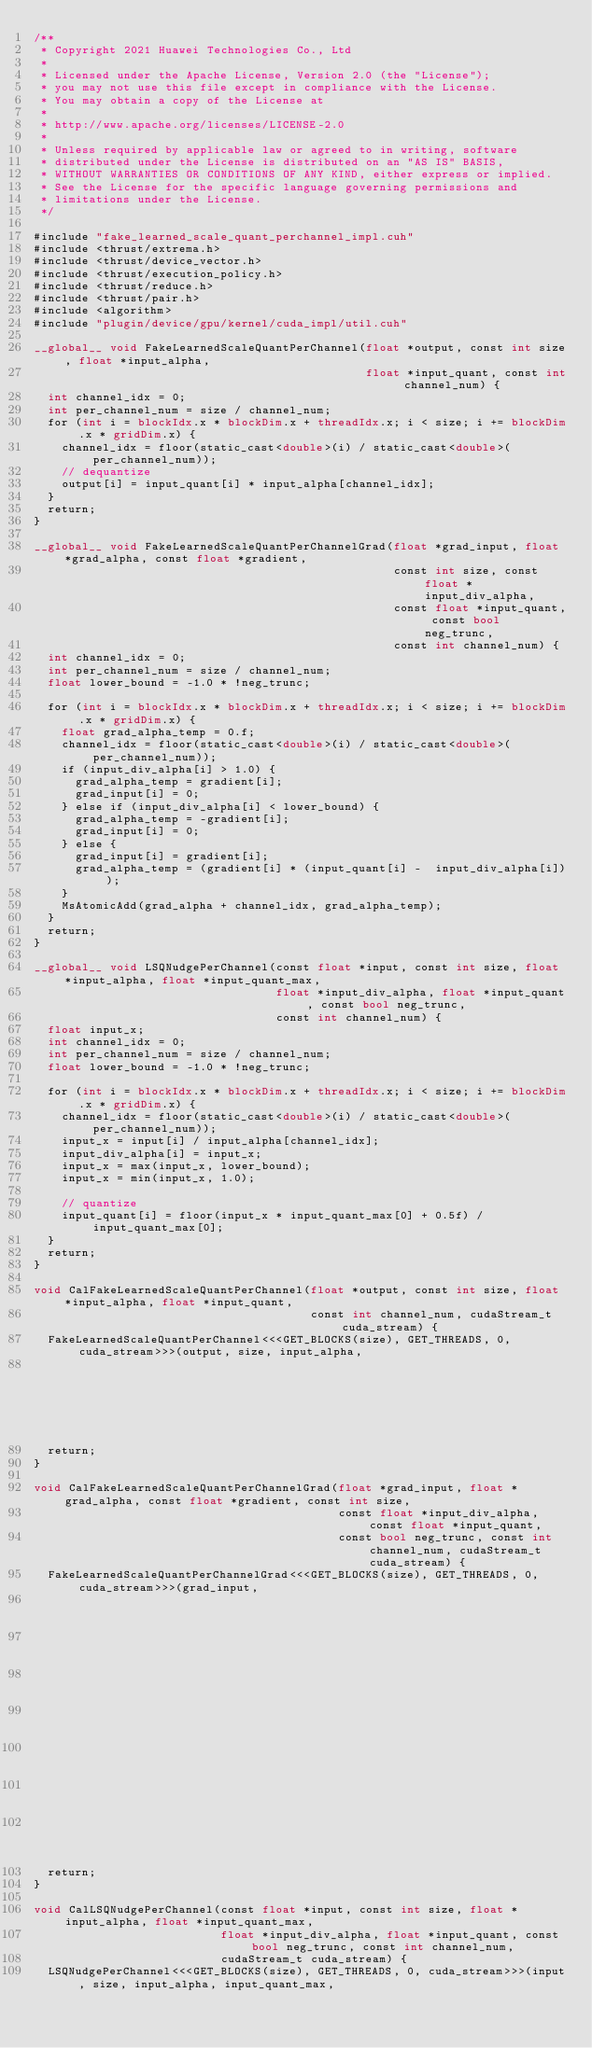<code> <loc_0><loc_0><loc_500><loc_500><_Cuda_>/**
 * Copyright 2021 Huawei Technologies Co., Ltd
 *
 * Licensed under the Apache License, Version 2.0 (the "License");
 * you may not use this file except in compliance with the License.
 * You may obtain a copy of the License at
 *
 * http://www.apache.org/licenses/LICENSE-2.0
 *
 * Unless required by applicable law or agreed to in writing, software
 * distributed under the License is distributed on an "AS IS" BASIS,
 * WITHOUT WARRANTIES OR CONDITIONS OF ANY KIND, either express or implied.
 * See the License for the specific language governing permissions and
 * limitations under the License.
 */

#include "fake_learned_scale_quant_perchannel_impl.cuh"
#include <thrust/extrema.h>
#include <thrust/device_vector.h>
#include <thrust/execution_policy.h>
#include <thrust/reduce.h>
#include <thrust/pair.h>
#include <algorithm>
#include "plugin/device/gpu/kernel/cuda_impl/util.cuh"

__global__ void FakeLearnedScaleQuantPerChannel(float *output, const int size, float *input_alpha,
                                                float *input_quant, const int channel_num) {
  int channel_idx = 0;
  int per_channel_num = size / channel_num;
  for (int i = blockIdx.x * blockDim.x + threadIdx.x; i < size; i += blockDim.x * gridDim.x) {
    channel_idx = floor(static_cast<double>(i) / static_cast<double>(per_channel_num));
    // dequantize
    output[i] = input_quant[i] * input_alpha[channel_idx];
  }
  return;
}

__global__ void FakeLearnedScaleQuantPerChannelGrad(float *grad_input, float *grad_alpha, const float *gradient,
                                                    const int size, const float *input_div_alpha,
                                                    const float *input_quant, const bool neg_trunc,
                                                    const int channel_num) {
  int channel_idx = 0;
  int per_channel_num = size / channel_num;
  float lower_bound = -1.0 * !neg_trunc;

  for (int i = blockIdx.x * blockDim.x + threadIdx.x; i < size; i += blockDim.x * gridDim.x) {
    float grad_alpha_temp = 0.f;
    channel_idx = floor(static_cast<double>(i) / static_cast<double>(per_channel_num));
    if (input_div_alpha[i] > 1.0) {
      grad_alpha_temp = gradient[i];
      grad_input[i] = 0;
    } else if (input_div_alpha[i] < lower_bound) {
      grad_alpha_temp = -gradient[i];
      grad_input[i] = 0;
    } else {
      grad_input[i] = gradient[i];
      grad_alpha_temp = (gradient[i] * (input_quant[i] -  input_div_alpha[i]));
    }
    MsAtomicAdd(grad_alpha + channel_idx, grad_alpha_temp);
  }
  return;
}

__global__ void LSQNudgePerChannel(const float *input, const int size, float *input_alpha, float *input_quant_max,
                                   float *input_div_alpha, float *input_quant, const bool neg_trunc,
                                   const int channel_num) {
  float input_x;
  int channel_idx = 0;
  int per_channel_num = size / channel_num;
  float lower_bound = -1.0 * !neg_trunc;

  for (int i = blockIdx.x * blockDim.x + threadIdx.x; i < size; i += blockDim.x * gridDim.x) {
    channel_idx = floor(static_cast<double>(i) / static_cast<double>(per_channel_num));
    input_x = input[i] / input_alpha[channel_idx];
    input_div_alpha[i] = input_x;
    input_x = max(input_x, lower_bound);
    input_x = min(input_x, 1.0);

    // quantize
    input_quant[i] = floor(input_x * input_quant_max[0] + 0.5f) / input_quant_max[0];
  }
  return;
}

void CalFakeLearnedScaleQuantPerChannel(float *output, const int size, float *input_alpha, float *input_quant,
                                        const int channel_num, cudaStream_t cuda_stream) {
  FakeLearnedScaleQuantPerChannel<<<GET_BLOCKS(size), GET_THREADS, 0, cuda_stream>>>(output, size, input_alpha,
                                                                                     input_quant, channel_num);
  return;
}

void CalFakeLearnedScaleQuantPerChannelGrad(float *grad_input, float *grad_alpha, const float *gradient, const int size,
                                            const float *input_div_alpha, const float *input_quant,
                                            const bool neg_trunc, const int channel_num, cudaStream_t cuda_stream) {
  FakeLearnedScaleQuantPerChannelGrad<<<GET_BLOCKS(size), GET_THREADS, 0, cuda_stream>>>(grad_input,
                                                                                         grad_alpha,
                                                                                         gradient,
                                                                                         size,
                                                                                         input_div_alpha,
                                                                                         input_quant,
                                                                                         neg_trunc,
                                                                                         channel_num);
  return;
}

void CalLSQNudgePerChannel(const float *input, const int size, float *input_alpha, float *input_quant_max,
                           float *input_div_alpha, float *input_quant, const bool neg_trunc, const int channel_num,
                           cudaStream_t cuda_stream) {
  LSQNudgePerChannel<<<GET_BLOCKS(size), GET_THREADS, 0, cuda_stream>>>(input, size, input_alpha, input_quant_max,</code> 